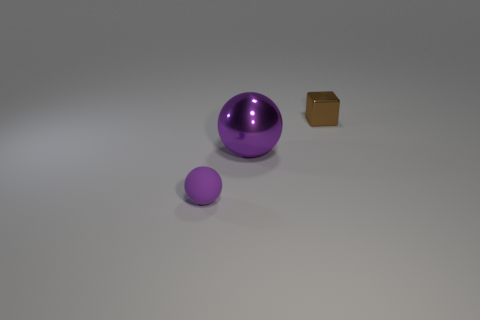How many purple spheres must be subtracted to get 1 purple spheres? 1 Subtract 1 spheres. How many spheres are left? 1 Add 1 cyan spheres. How many objects exist? 4 Subtract all gray spheres. How many purple blocks are left? 0 Add 1 purple things. How many purple things are left? 3 Add 2 brown objects. How many brown objects exist? 3 Subtract 0 cyan balls. How many objects are left? 3 Subtract all balls. How many objects are left? 1 Subtract all green cubes. Subtract all purple spheres. How many cubes are left? 1 Subtract all big green matte spheres. Subtract all large purple metallic things. How many objects are left? 2 